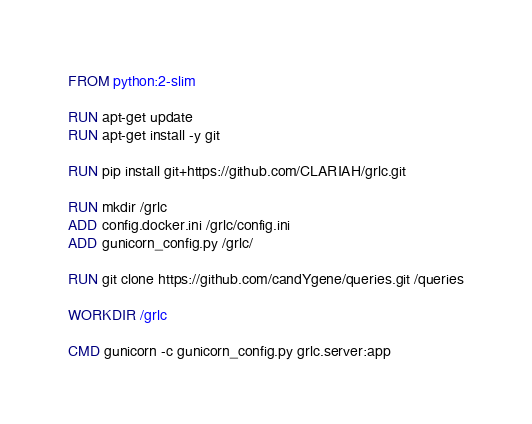Convert code to text. <code><loc_0><loc_0><loc_500><loc_500><_Dockerfile_>FROM python:2-slim

RUN apt-get update
RUN apt-get install -y git

RUN pip install git+https://github.com/CLARIAH/grlc.git

RUN mkdir /grlc
ADD config.docker.ini /grlc/config.ini
ADD gunicorn_config.py /grlc/

RUN git clone https://github.com/candYgene/queries.git /queries

WORKDIR /grlc

CMD gunicorn -c gunicorn_config.py grlc.server:app
</code> 